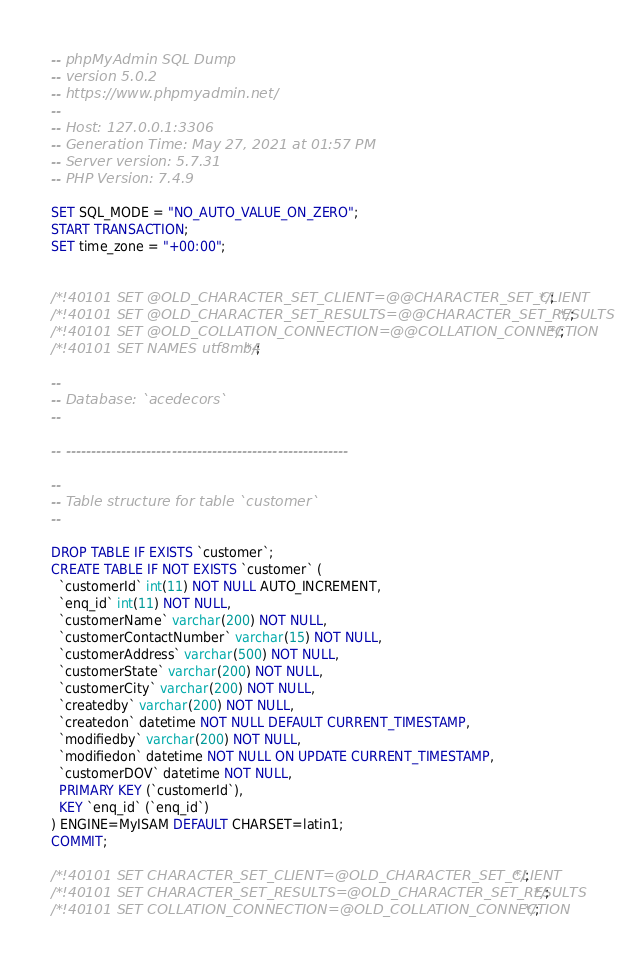Convert code to text. <code><loc_0><loc_0><loc_500><loc_500><_SQL_>-- phpMyAdmin SQL Dump
-- version 5.0.2
-- https://www.phpmyadmin.net/
--
-- Host: 127.0.0.1:3306
-- Generation Time: May 27, 2021 at 01:57 PM
-- Server version: 5.7.31
-- PHP Version: 7.4.9

SET SQL_MODE = "NO_AUTO_VALUE_ON_ZERO";
START TRANSACTION;
SET time_zone = "+00:00";


/*!40101 SET @OLD_CHARACTER_SET_CLIENT=@@CHARACTER_SET_CLIENT */;
/*!40101 SET @OLD_CHARACTER_SET_RESULTS=@@CHARACTER_SET_RESULTS */;
/*!40101 SET @OLD_COLLATION_CONNECTION=@@COLLATION_CONNECTION */;
/*!40101 SET NAMES utf8mb4 */;

--
-- Database: `acedecors`
--

-- --------------------------------------------------------

--
-- Table structure for table `customer`
--

DROP TABLE IF EXISTS `customer`;
CREATE TABLE IF NOT EXISTS `customer` (
  `customerId` int(11) NOT NULL AUTO_INCREMENT,
  `enq_id` int(11) NOT NULL,
  `customerName` varchar(200) NOT NULL,
  `customerContactNumber` varchar(15) NOT NULL,
  `customerAddress` varchar(500) NOT NULL,
  `customerState` varchar(200) NOT NULL,
  `customerCity` varchar(200) NOT NULL,
  `createdby` varchar(200) NOT NULL,
  `createdon` datetime NOT NULL DEFAULT CURRENT_TIMESTAMP,
  `modifiedby` varchar(200) NOT NULL,
  `modifiedon` datetime NOT NULL ON UPDATE CURRENT_TIMESTAMP,
  `customerDOV` datetime NOT NULL,
  PRIMARY KEY (`customerId`),
  KEY `enq_id` (`enq_id`)
) ENGINE=MyISAM DEFAULT CHARSET=latin1;
COMMIT;

/*!40101 SET CHARACTER_SET_CLIENT=@OLD_CHARACTER_SET_CLIENT */;
/*!40101 SET CHARACTER_SET_RESULTS=@OLD_CHARACTER_SET_RESULTS */;
/*!40101 SET COLLATION_CONNECTION=@OLD_COLLATION_CONNECTION */;
</code> 